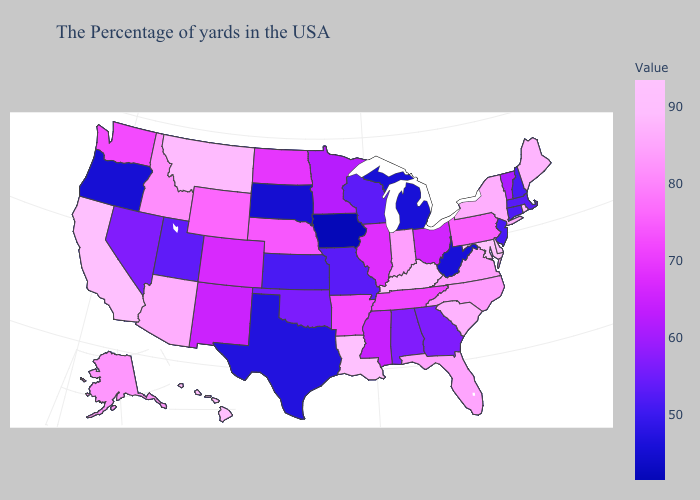Which states have the lowest value in the Northeast?
Give a very brief answer. New Hampshire. Does Maryland have the highest value in the USA?
Keep it brief. Yes. Does Wyoming have the lowest value in the USA?
Be succinct. No. Among the states that border California , does Nevada have the highest value?
Keep it brief. No. Is the legend a continuous bar?
Keep it brief. Yes. Which states have the lowest value in the MidWest?
Keep it brief. Iowa. Does Alaska have a lower value than Washington?
Concise answer only. No. Does Maryland have the highest value in the South?
Keep it brief. Yes. 